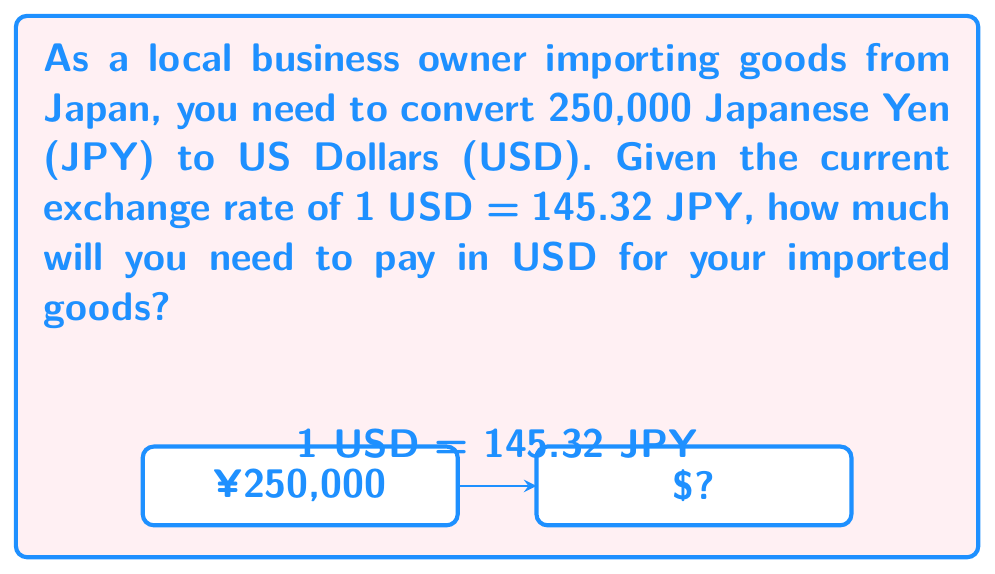Can you answer this question? To solve this problem, we need to convert JPY to USD using the given exchange rate. We can do this by dividing the amount in JPY by the exchange rate:

1. Set up the division:
   $$ \text{USD} = \frac{\text{JPY}}{\text{Exchange Rate}} $$

2. Plug in the values:
   $$ \text{USD} = \frac{250,000}{145.32} $$

3. Perform the division:
   $$ \text{USD} = 1,720.9605 $$

4. Round to two decimal places since currency is typically expressed with cents:
   $$ \text{USD} = 1,720.96 $$

Therefore, 250,000 JPY is equivalent to $1,720.96 USD at the given exchange rate.
Answer: $1,720.96 